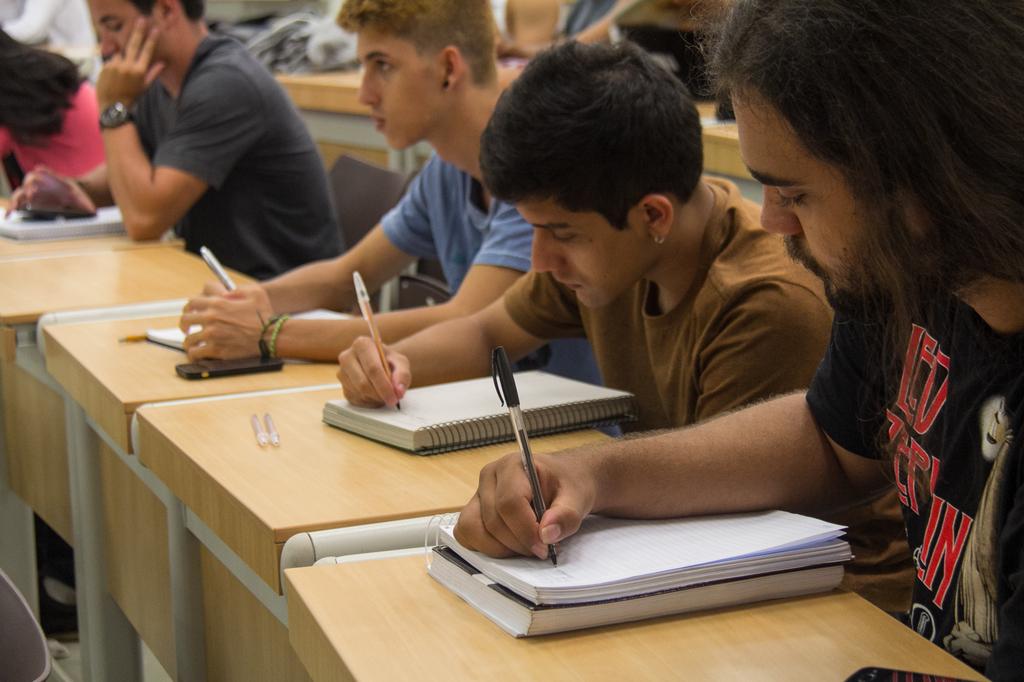What color is the text on the black shirt?
Provide a short and direct response. Red. What band is on the guy's t-shirt all the way to the right?
Offer a terse response. Led zeppelin. 